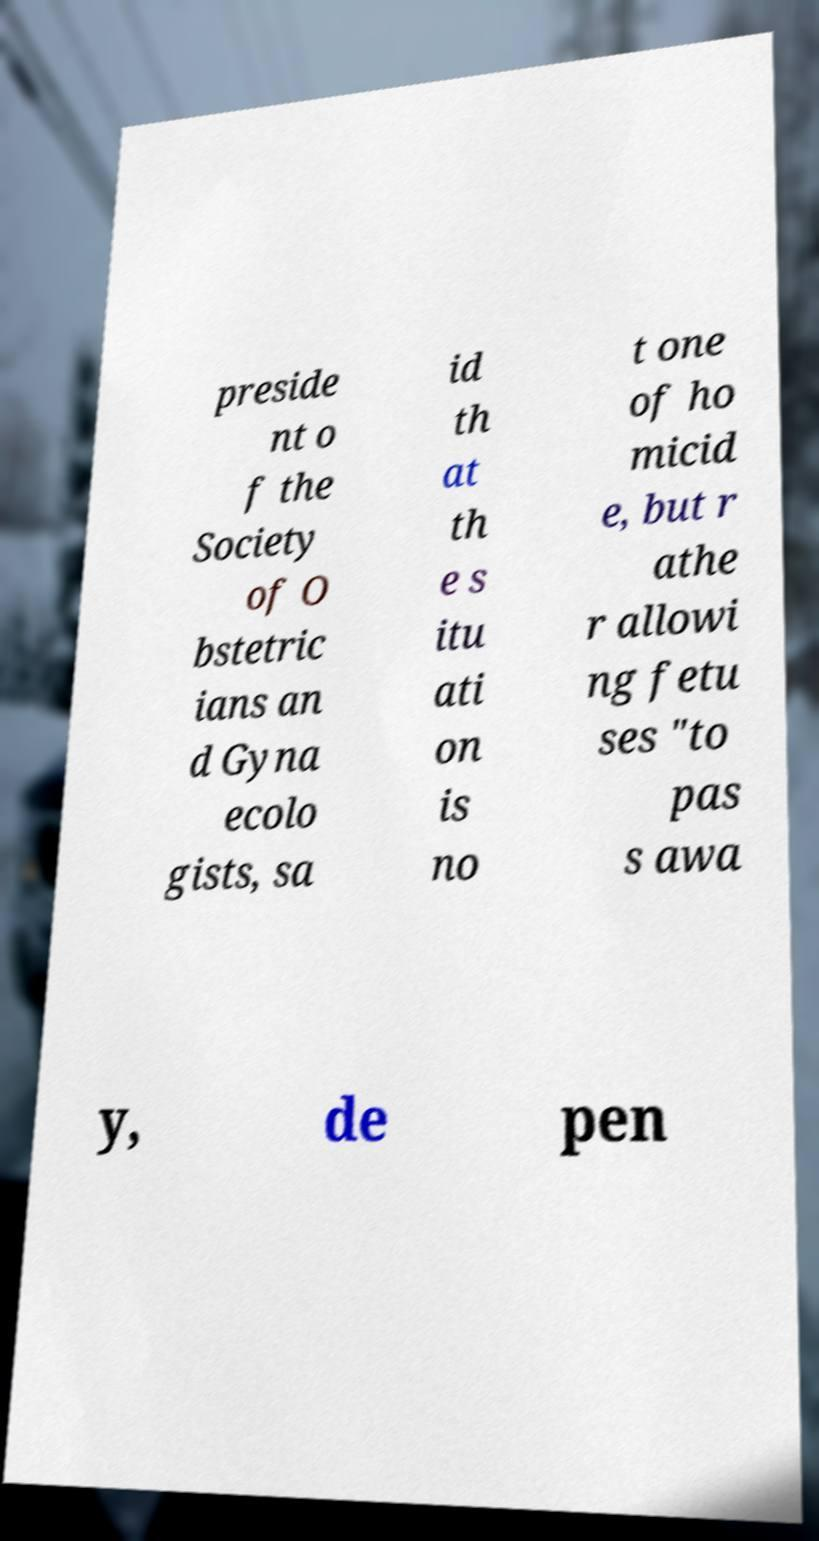For documentation purposes, I need the text within this image transcribed. Could you provide that? preside nt o f the Society of O bstetric ians an d Gyna ecolo gists, sa id th at th e s itu ati on is no t one of ho micid e, but r athe r allowi ng fetu ses "to pas s awa y, de pen 